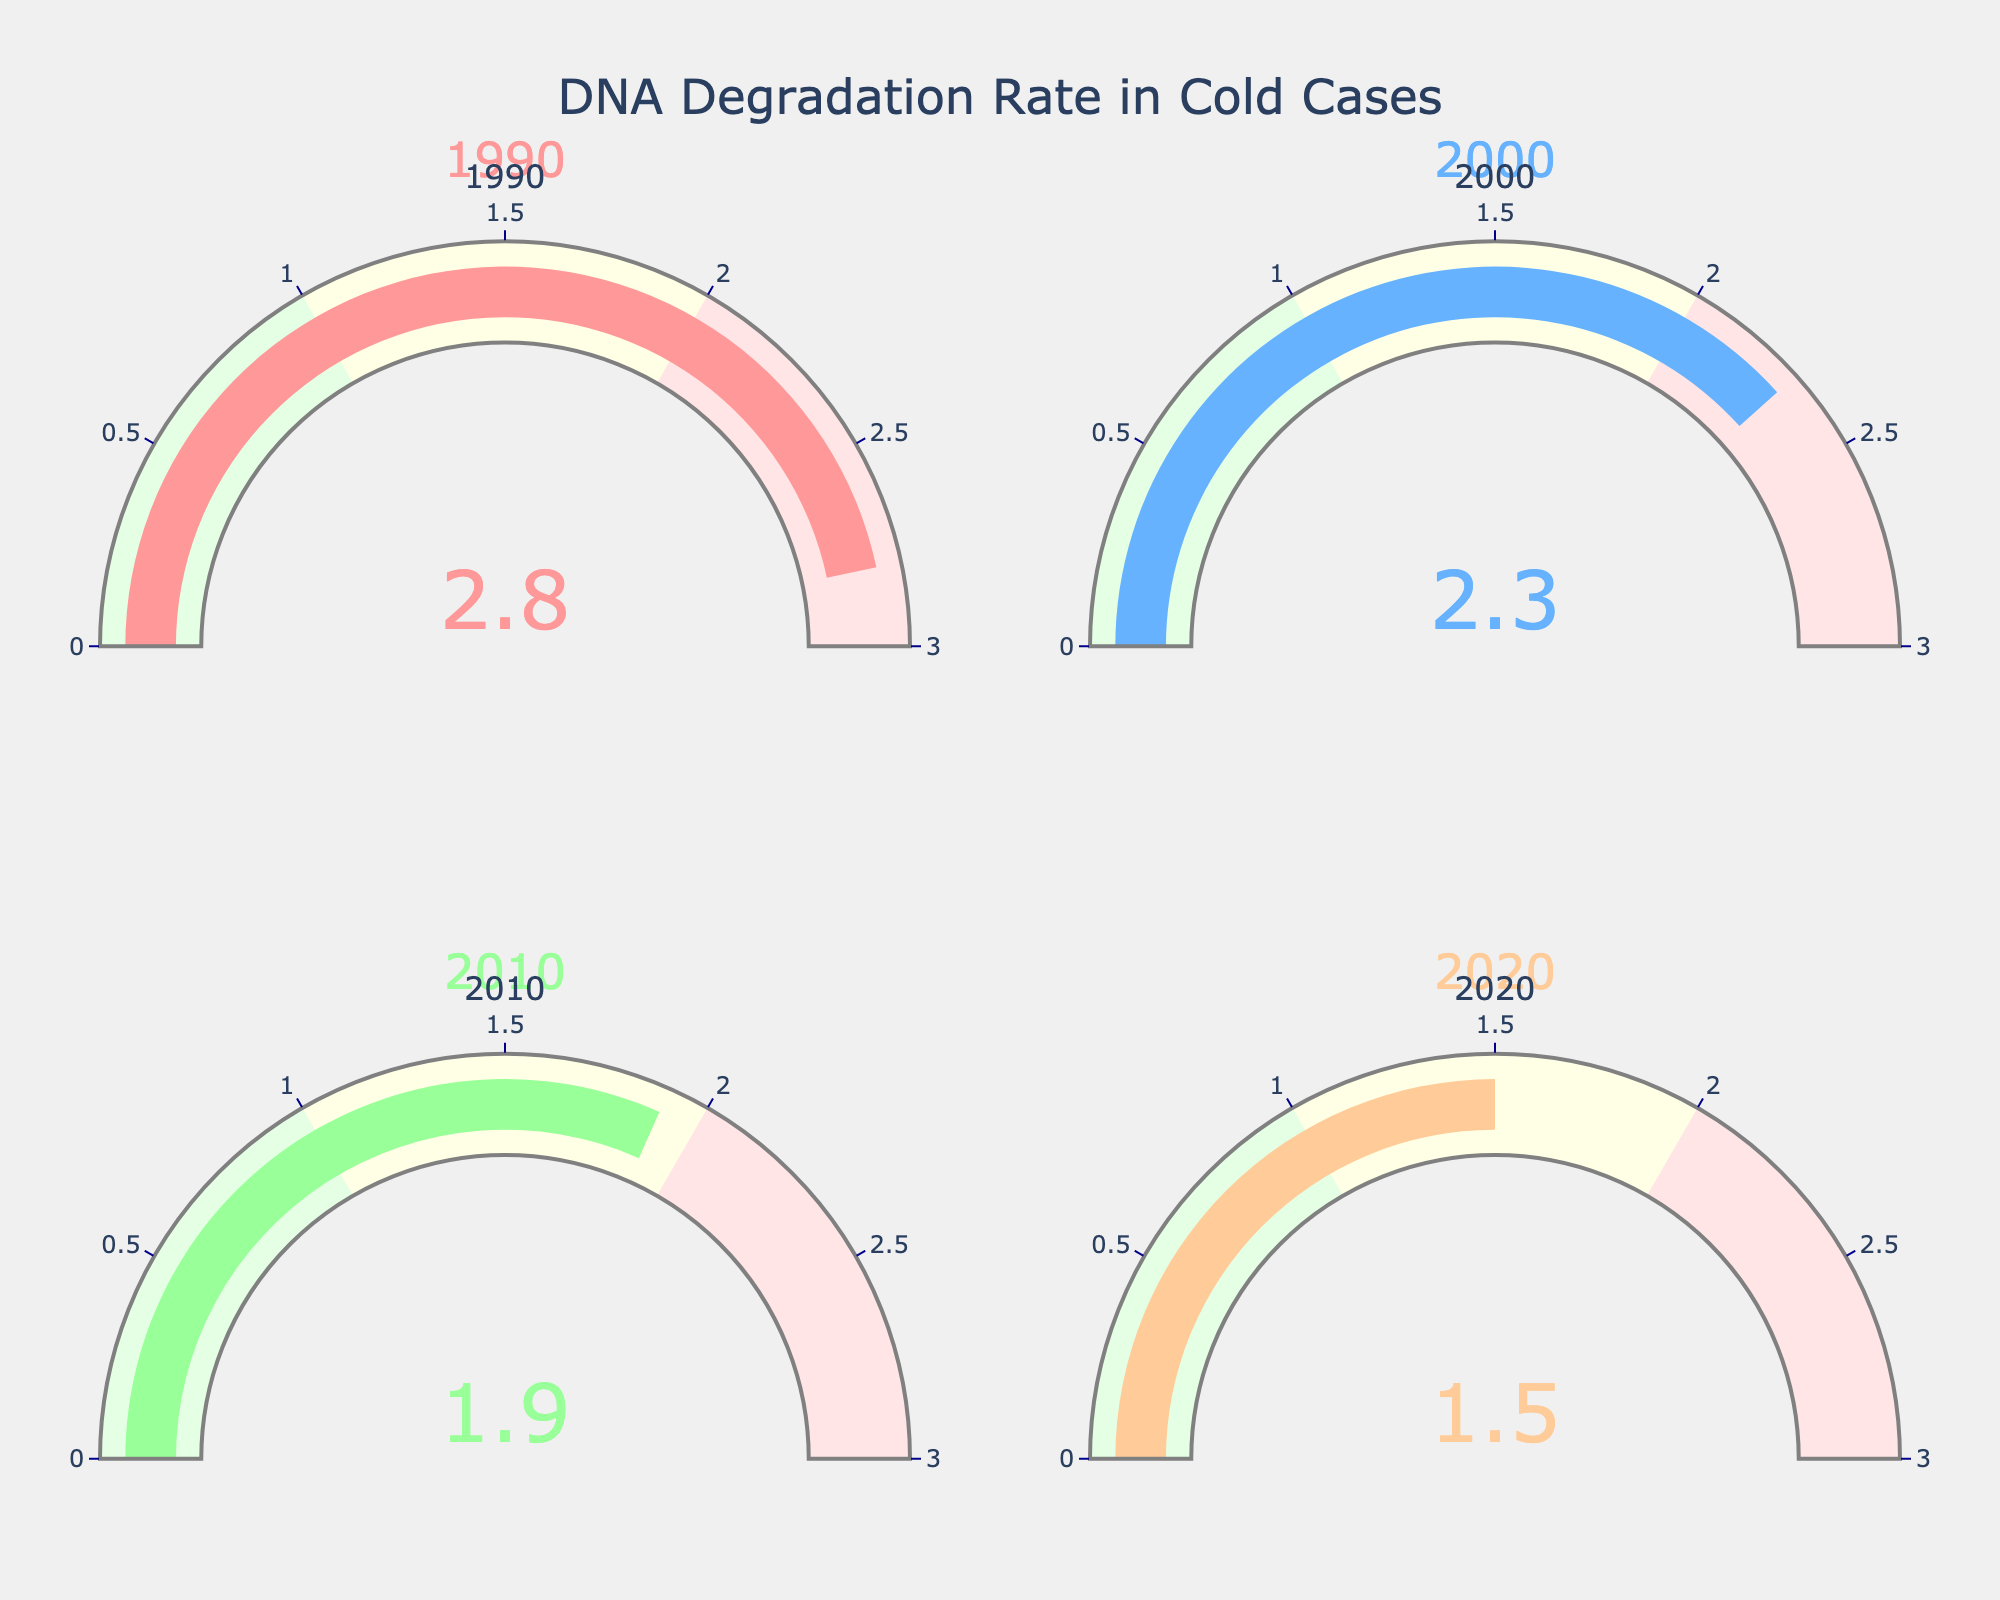What's the rate of DNA degradation in the year 1990? The year 1990 is represented in the top-left gauge, which shows a value of 2.8.
Answer: 2.8 Which year has the lowest rate of DNA degradation? By comparing the values on each gauge, the year 2020 has the lowest rate of DNA degradation at 1.5.
Answer: 2020 What is the difference in DNA degradation rates between 1990 and 2020? Subtract the 2020 value (1.5) from the 1990 value (2.8): 2.8 - 1.5 = 1.3.
Answer: 1.3 How has the rate of DNA degradation trended over the years shown? The rates decrease progressively with each year: 2.8 in 1990, 2.3 in 2000, 1.9 in 2010, and 1.5 in 2020.
Answer: Decreased What is the average rate of DNA degradation over all four years? Add up the rates (2.8 + 2.3 + 1.9 + 1.5) to get 8.5, then divide by 4: 8.5 / 4 = 2.125.
Answer: 2.125 How much lower is the DNA degradation rate in 2010 compared to 1990? Subtract the 2010 value (1.9) from the 1990 value (2.8): 2.8 - 1.9 = 0.9.
Answer: 0.9 Which year marks the first time the DNA degradation rate fell below 2.0? By looking at the gauges, the year 2010 shows the rate dropping below 2.0 for the first time, at 1.9.
Answer: 2010 What color represents the year 2000 in the figure? The gauge for the year 2000 shows a blue-colored bar.
Answer: Blue What is the total sum of the DNA degradation rates for all years shown? Add up the values for each year: 2.8 + 2.3 + 1.9 + 1.5 = 8.5.
Answer: 8.5 Is the rate of DNA degradation more than 2.0 in the year 2000? The gauge for 2000 shows a value of 2.3, which is more than 2.0.
Answer: Yes 